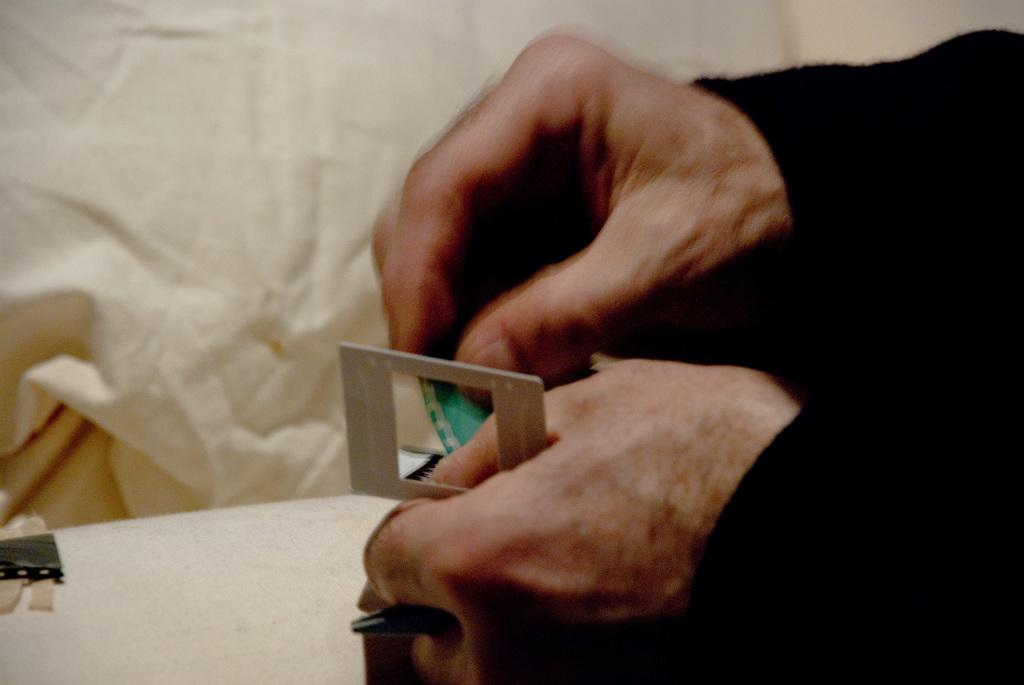What part of a person can be seen on the right side of the image? There are hands of a person visible on the right side of the image. What can be seen in the background of the image? There is a white cloth in the background of the image. What type of account does the person have with the quince in the image? There is no account or quince present in the image; only the hands of a person and a white cloth in the background are visible. 